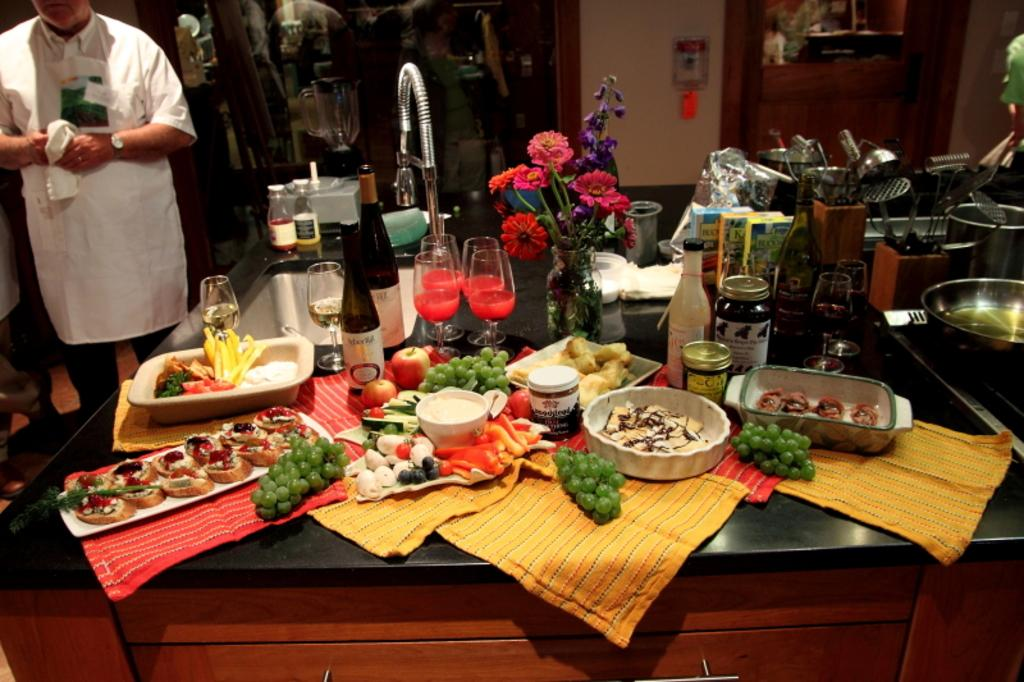What type of surface is visible in the image? There is a kitchen platform in the image. What items can be seen on the platform? There are bottles, glasses, fruits, vegetables, trays, and a tap on the platform. Is there anyone present in the image? Yes, there is a person standing on the left side of the image. What type of pest can be seen crawling on the vegetables in the image? There are no pests visible in the image; it only shows the vegetables on the platform. 